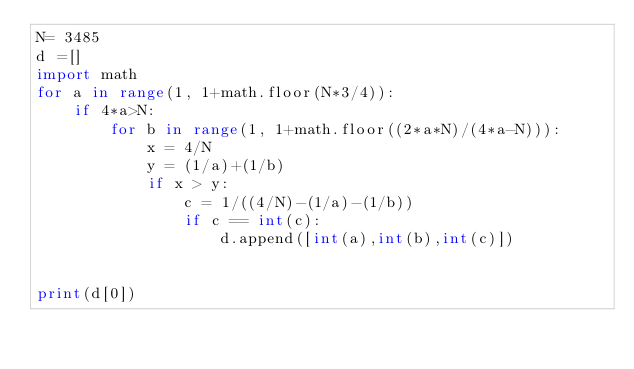Convert code to text. <code><loc_0><loc_0><loc_500><loc_500><_Python_>N= 3485
d =[]
import math
for a in range(1, 1+math.floor(N*3/4)):
    if 4*a>N:
        for b in range(1, 1+math.floor((2*a*N)/(4*a-N))):
            x = 4/N
            y = (1/a)+(1/b)
            if x > y:
                c = 1/((4/N)-(1/a)-(1/b))
                if c == int(c):
                    d.append([int(a),int(b),int(c)])

                    
print(d[0])</code> 